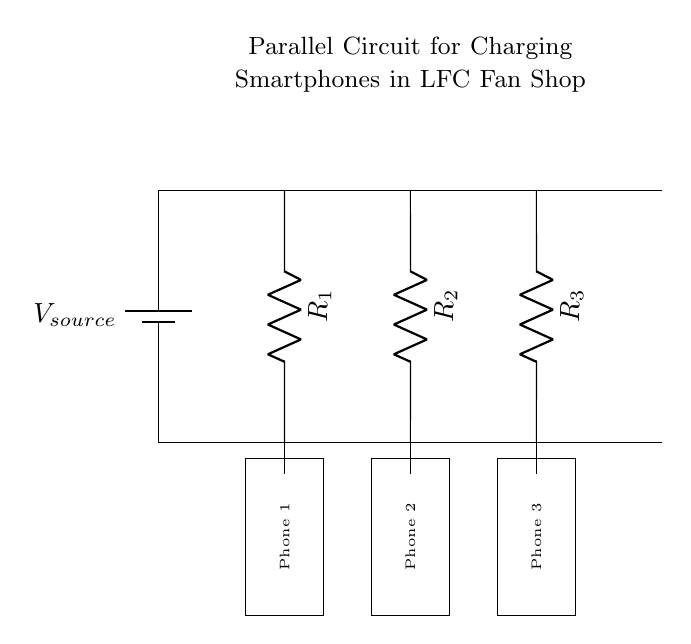What does the battery represent in this circuit? The battery in the circuit represents the voltage source, supplying the necessary electrical energy to the circuit.
Answer: Voltage source How many smartphones are being charged in this circuit? There are three smartphones listed in the circuit, each connected to its own branch.
Answer: Three What type of circuit is this? This is a parallel circuit, as the components are connected across the same voltage source with multiple branches.
Answer: Parallel What do R1, R2, and R3 represent? R1, R2, and R3 represent resistors that could symbolize the charging resistance for each smartphone in the circuit.
Answer: Resistors How does the voltage across each smartphone compare? The voltage across each smartphone is the same as the source voltage since they are connected in parallel.
Answer: Same What is the main advantage of using a parallel circuit for charging devices? The main advantage is allowing multiple devices to charge simultaneously without affecting each other's charging rate.
Answer: Simultaneous charging 